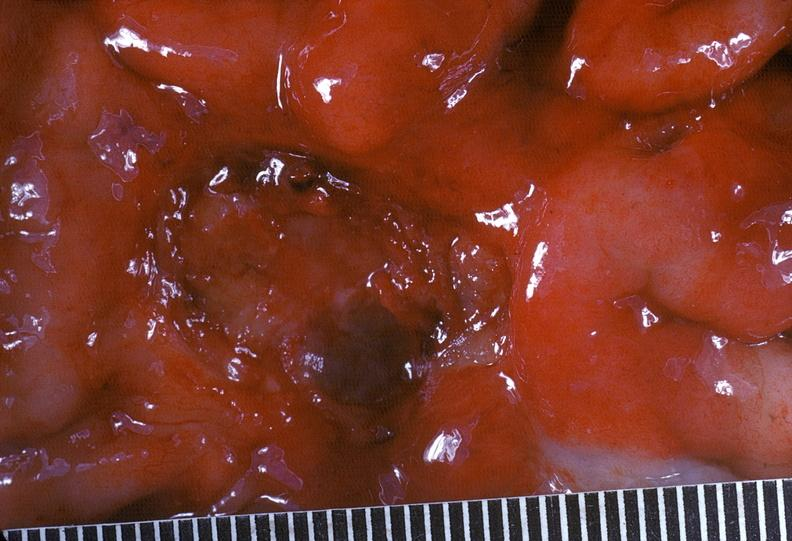s coronary atherosclerosis present?
Answer the question using a single word or phrase. No 